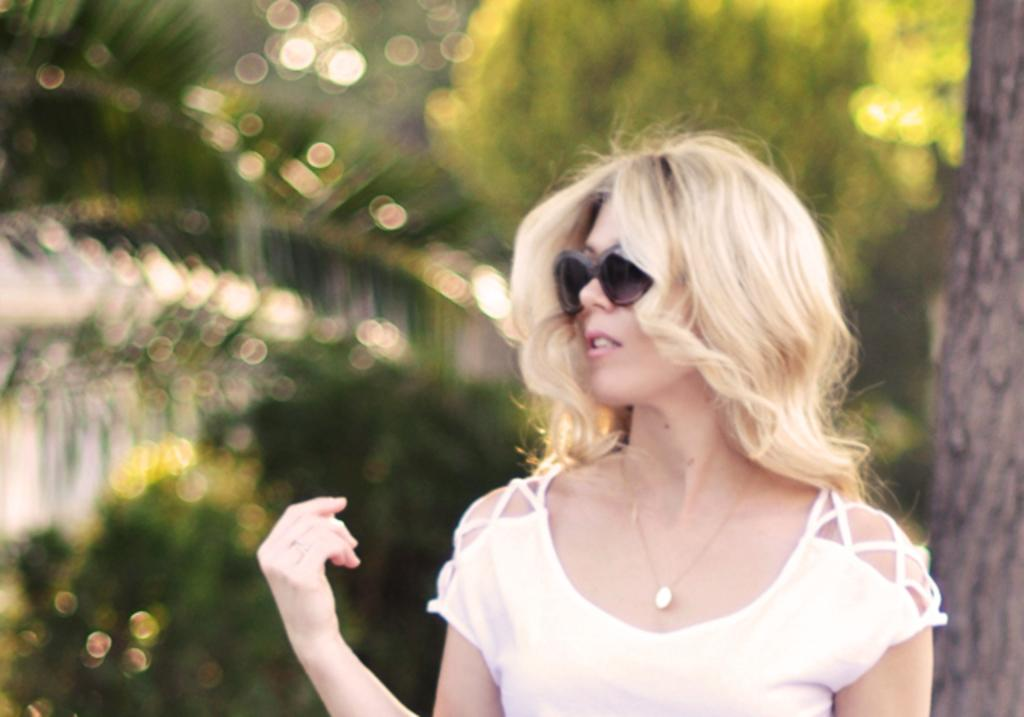Who is the main subject in the picture? There is a woman in the picture. What is the woman wearing on her face? The woman is wearing goggles. What can be seen in the background of the picture? There is a tree in the background of the picture. What type of animal is the woman questioning in the image? There is no animal present in the image, and the woman is not questioning anyone. 